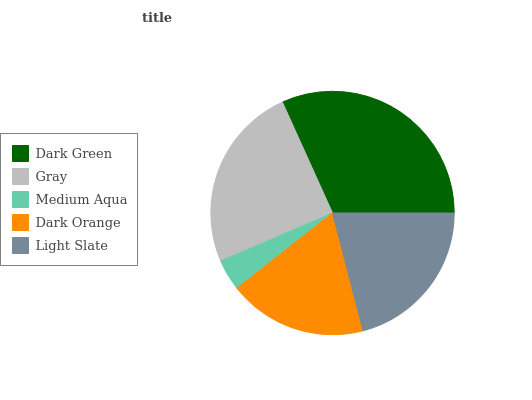Is Medium Aqua the minimum?
Answer yes or no. Yes. Is Dark Green the maximum?
Answer yes or no. Yes. Is Gray the minimum?
Answer yes or no. No. Is Gray the maximum?
Answer yes or no. No. Is Dark Green greater than Gray?
Answer yes or no. Yes. Is Gray less than Dark Green?
Answer yes or no. Yes. Is Gray greater than Dark Green?
Answer yes or no. No. Is Dark Green less than Gray?
Answer yes or no. No. Is Light Slate the high median?
Answer yes or no. Yes. Is Light Slate the low median?
Answer yes or no. Yes. Is Gray the high median?
Answer yes or no. No. Is Dark Orange the low median?
Answer yes or no. No. 